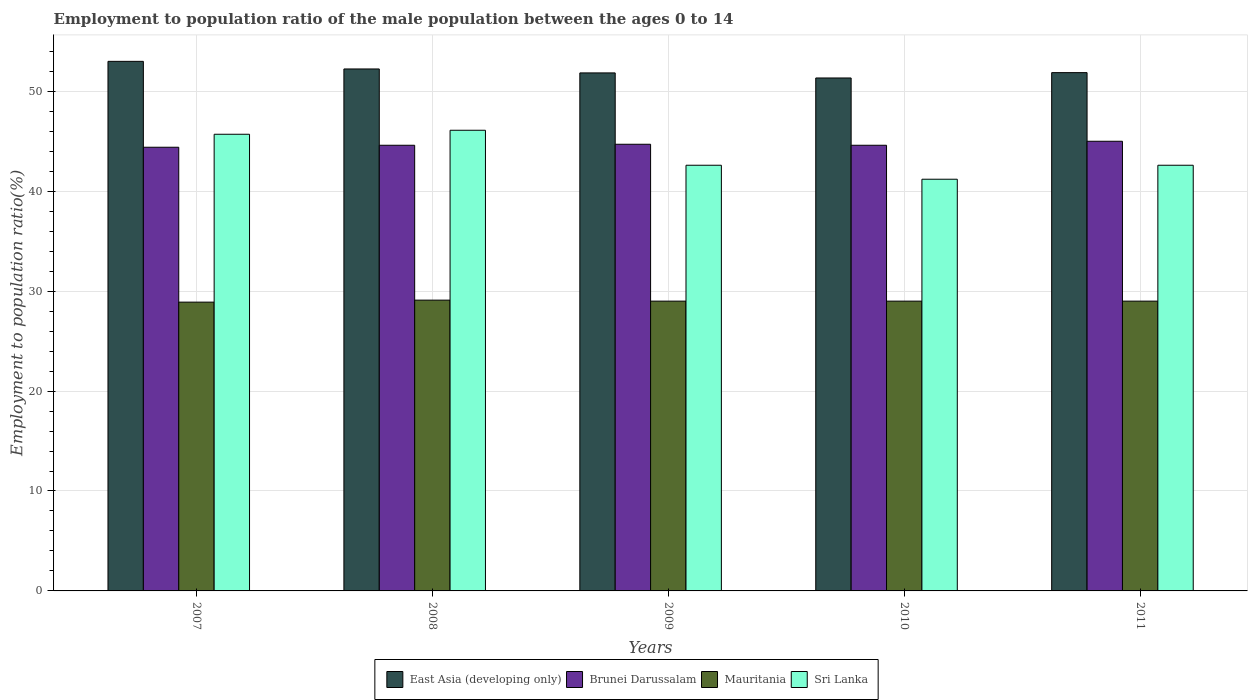How many different coloured bars are there?
Your answer should be compact. 4. How many groups of bars are there?
Offer a terse response. 5. Are the number of bars on each tick of the X-axis equal?
Provide a succinct answer. Yes. Across all years, what is the minimum employment to population ratio in Mauritania?
Your response must be concise. 28.9. What is the total employment to population ratio in Sri Lanka in the graph?
Provide a short and direct response. 218.2. What is the difference between the employment to population ratio in Brunei Darussalam in 2009 and that in 2011?
Ensure brevity in your answer.  -0.3. What is the difference between the employment to population ratio in Sri Lanka in 2007 and the employment to population ratio in Mauritania in 2009?
Offer a terse response. 16.7. What is the average employment to population ratio in East Asia (developing only) per year?
Make the answer very short. 52.05. In the year 2008, what is the difference between the employment to population ratio in Brunei Darussalam and employment to population ratio in Sri Lanka?
Ensure brevity in your answer.  -1.5. What is the ratio of the employment to population ratio in Mauritania in 2007 to that in 2008?
Ensure brevity in your answer.  0.99. Is the difference between the employment to population ratio in Brunei Darussalam in 2007 and 2010 greater than the difference between the employment to population ratio in Sri Lanka in 2007 and 2010?
Your answer should be compact. No. What is the difference between the highest and the second highest employment to population ratio in Brunei Darussalam?
Offer a very short reply. 0.3. What is the difference between the highest and the lowest employment to population ratio in Mauritania?
Make the answer very short. 0.2. Is the sum of the employment to population ratio in Sri Lanka in 2007 and 2009 greater than the maximum employment to population ratio in Mauritania across all years?
Your answer should be compact. Yes. What does the 2nd bar from the left in 2011 represents?
Offer a terse response. Brunei Darussalam. What does the 1st bar from the right in 2007 represents?
Your answer should be compact. Sri Lanka. Is it the case that in every year, the sum of the employment to population ratio in Sri Lanka and employment to population ratio in Mauritania is greater than the employment to population ratio in East Asia (developing only)?
Your answer should be compact. Yes. Are all the bars in the graph horizontal?
Provide a succinct answer. No. Does the graph contain any zero values?
Provide a short and direct response. No. How many legend labels are there?
Keep it short and to the point. 4. What is the title of the graph?
Offer a very short reply. Employment to population ratio of the male population between the ages 0 to 14. What is the label or title of the Y-axis?
Your answer should be compact. Employment to population ratio(%). What is the Employment to population ratio(%) of East Asia (developing only) in 2007?
Provide a succinct answer. 53. What is the Employment to population ratio(%) in Brunei Darussalam in 2007?
Give a very brief answer. 44.4. What is the Employment to population ratio(%) of Mauritania in 2007?
Your response must be concise. 28.9. What is the Employment to population ratio(%) of Sri Lanka in 2007?
Offer a very short reply. 45.7. What is the Employment to population ratio(%) in East Asia (developing only) in 2008?
Your answer should be very brief. 52.23. What is the Employment to population ratio(%) in Brunei Darussalam in 2008?
Offer a very short reply. 44.6. What is the Employment to population ratio(%) in Mauritania in 2008?
Provide a succinct answer. 29.1. What is the Employment to population ratio(%) of Sri Lanka in 2008?
Keep it short and to the point. 46.1. What is the Employment to population ratio(%) in East Asia (developing only) in 2009?
Your answer should be compact. 51.84. What is the Employment to population ratio(%) of Brunei Darussalam in 2009?
Your answer should be very brief. 44.7. What is the Employment to population ratio(%) in Sri Lanka in 2009?
Give a very brief answer. 42.6. What is the Employment to population ratio(%) in East Asia (developing only) in 2010?
Your answer should be compact. 51.33. What is the Employment to population ratio(%) in Brunei Darussalam in 2010?
Ensure brevity in your answer.  44.6. What is the Employment to population ratio(%) in Mauritania in 2010?
Provide a short and direct response. 29. What is the Employment to population ratio(%) in Sri Lanka in 2010?
Give a very brief answer. 41.2. What is the Employment to population ratio(%) of East Asia (developing only) in 2011?
Ensure brevity in your answer.  51.87. What is the Employment to population ratio(%) of Brunei Darussalam in 2011?
Keep it short and to the point. 45. What is the Employment to population ratio(%) of Sri Lanka in 2011?
Give a very brief answer. 42.6. Across all years, what is the maximum Employment to population ratio(%) of East Asia (developing only)?
Your response must be concise. 53. Across all years, what is the maximum Employment to population ratio(%) of Brunei Darussalam?
Offer a very short reply. 45. Across all years, what is the maximum Employment to population ratio(%) of Mauritania?
Your answer should be very brief. 29.1. Across all years, what is the maximum Employment to population ratio(%) in Sri Lanka?
Your answer should be very brief. 46.1. Across all years, what is the minimum Employment to population ratio(%) of East Asia (developing only)?
Ensure brevity in your answer.  51.33. Across all years, what is the minimum Employment to population ratio(%) in Brunei Darussalam?
Your answer should be compact. 44.4. Across all years, what is the minimum Employment to population ratio(%) in Mauritania?
Your answer should be compact. 28.9. Across all years, what is the minimum Employment to population ratio(%) of Sri Lanka?
Ensure brevity in your answer.  41.2. What is the total Employment to population ratio(%) in East Asia (developing only) in the graph?
Your answer should be compact. 260.27. What is the total Employment to population ratio(%) in Brunei Darussalam in the graph?
Your response must be concise. 223.3. What is the total Employment to population ratio(%) of Mauritania in the graph?
Your answer should be compact. 145. What is the total Employment to population ratio(%) of Sri Lanka in the graph?
Your answer should be compact. 218.2. What is the difference between the Employment to population ratio(%) in East Asia (developing only) in 2007 and that in 2008?
Your answer should be compact. 0.76. What is the difference between the Employment to population ratio(%) in Sri Lanka in 2007 and that in 2008?
Offer a terse response. -0.4. What is the difference between the Employment to population ratio(%) in East Asia (developing only) in 2007 and that in 2009?
Make the answer very short. 1.16. What is the difference between the Employment to population ratio(%) in Brunei Darussalam in 2007 and that in 2009?
Your response must be concise. -0.3. What is the difference between the Employment to population ratio(%) of Mauritania in 2007 and that in 2009?
Provide a short and direct response. -0.1. What is the difference between the Employment to population ratio(%) of Sri Lanka in 2007 and that in 2009?
Ensure brevity in your answer.  3.1. What is the difference between the Employment to population ratio(%) of East Asia (developing only) in 2007 and that in 2010?
Offer a very short reply. 1.66. What is the difference between the Employment to population ratio(%) in Mauritania in 2007 and that in 2010?
Make the answer very short. -0.1. What is the difference between the Employment to population ratio(%) of East Asia (developing only) in 2007 and that in 2011?
Ensure brevity in your answer.  1.13. What is the difference between the Employment to population ratio(%) of Brunei Darussalam in 2007 and that in 2011?
Your response must be concise. -0.6. What is the difference between the Employment to population ratio(%) of Sri Lanka in 2007 and that in 2011?
Offer a very short reply. 3.1. What is the difference between the Employment to population ratio(%) of East Asia (developing only) in 2008 and that in 2009?
Your response must be concise. 0.39. What is the difference between the Employment to population ratio(%) in East Asia (developing only) in 2008 and that in 2010?
Your answer should be compact. 0.9. What is the difference between the Employment to population ratio(%) in Mauritania in 2008 and that in 2010?
Your answer should be compact. 0.1. What is the difference between the Employment to population ratio(%) of East Asia (developing only) in 2008 and that in 2011?
Ensure brevity in your answer.  0.37. What is the difference between the Employment to population ratio(%) of Mauritania in 2008 and that in 2011?
Provide a succinct answer. 0.1. What is the difference between the Employment to population ratio(%) in Sri Lanka in 2008 and that in 2011?
Your response must be concise. 3.5. What is the difference between the Employment to population ratio(%) of East Asia (developing only) in 2009 and that in 2010?
Provide a succinct answer. 0.51. What is the difference between the Employment to population ratio(%) of Brunei Darussalam in 2009 and that in 2010?
Your answer should be very brief. 0.1. What is the difference between the Employment to population ratio(%) of Mauritania in 2009 and that in 2010?
Ensure brevity in your answer.  0. What is the difference between the Employment to population ratio(%) of East Asia (developing only) in 2009 and that in 2011?
Give a very brief answer. -0.03. What is the difference between the Employment to population ratio(%) in Mauritania in 2009 and that in 2011?
Provide a short and direct response. 0. What is the difference between the Employment to population ratio(%) in Sri Lanka in 2009 and that in 2011?
Your answer should be compact. 0. What is the difference between the Employment to population ratio(%) in East Asia (developing only) in 2010 and that in 2011?
Your answer should be very brief. -0.53. What is the difference between the Employment to population ratio(%) in Sri Lanka in 2010 and that in 2011?
Keep it short and to the point. -1.4. What is the difference between the Employment to population ratio(%) in East Asia (developing only) in 2007 and the Employment to population ratio(%) in Brunei Darussalam in 2008?
Your answer should be compact. 8.4. What is the difference between the Employment to population ratio(%) in East Asia (developing only) in 2007 and the Employment to population ratio(%) in Mauritania in 2008?
Provide a short and direct response. 23.9. What is the difference between the Employment to population ratio(%) of East Asia (developing only) in 2007 and the Employment to population ratio(%) of Sri Lanka in 2008?
Provide a short and direct response. 6.9. What is the difference between the Employment to population ratio(%) of Brunei Darussalam in 2007 and the Employment to population ratio(%) of Mauritania in 2008?
Make the answer very short. 15.3. What is the difference between the Employment to population ratio(%) of Mauritania in 2007 and the Employment to population ratio(%) of Sri Lanka in 2008?
Offer a terse response. -17.2. What is the difference between the Employment to population ratio(%) in East Asia (developing only) in 2007 and the Employment to population ratio(%) in Brunei Darussalam in 2009?
Ensure brevity in your answer.  8.3. What is the difference between the Employment to population ratio(%) of East Asia (developing only) in 2007 and the Employment to population ratio(%) of Mauritania in 2009?
Offer a terse response. 24. What is the difference between the Employment to population ratio(%) in East Asia (developing only) in 2007 and the Employment to population ratio(%) in Sri Lanka in 2009?
Keep it short and to the point. 10.4. What is the difference between the Employment to population ratio(%) in Mauritania in 2007 and the Employment to population ratio(%) in Sri Lanka in 2009?
Your answer should be compact. -13.7. What is the difference between the Employment to population ratio(%) in East Asia (developing only) in 2007 and the Employment to population ratio(%) in Brunei Darussalam in 2010?
Give a very brief answer. 8.4. What is the difference between the Employment to population ratio(%) of East Asia (developing only) in 2007 and the Employment to population ratio(%) of Mauritania in 2010?
Provide a short and direct response. 24. What is the difference between the Employment to population ratio(%) of East Asia (developing only) in 2007 and the Employment to population ratio(%) of Sri Lanka in 2010?
Offer a terse response. 11.8. What is the difference between the Employment to population ratio(%) of Brunei Darussalam in 2007 and the Employment to population ratio(%) of Mauritania in 2010?
Offer a very short reply. 15.4. What is the difference between the Employment to population ratio(%) in East Asia (developing only) in 2007 and the Employment to population ratio(%) in Brunei Darussalam in 2011?
Offer a very short reply. 8. What is the difference between the Employment to population ratio(%) in East Asia (developing only) in 2007 and the Employment to population ratio(%) in Mauritania in 2011?
Your answer should be very brief. 24. What is the difference between the Employment to population ratio(%) of East Asia (developing only) in 2007 and the Employment to population ratio(%) of Sri Lanka in 2011?
Provide a short and direct response. 10.4. What is the difference between the Employment to population ratio(%) of Brunei Darussalam in 2007 and the Employment to population ratio(%) of Mauritania in 2011?
Make the answer very short. 15.4. What is the difference between the Employment to population ratio(%) of Brunei Darussalam in 2007 and the Employment to population ratio(%) of Sri Lanka in 2011?
Keep it short and to the point. 1.8. What is the difference between the Employment to population ratio(%) of Mauritania in 2007 and the Employment to population ratio(%) of Sri Lanka in 2011?
Offer a terse response. -13.7. What is the difference between the Employment to population ratio(%) of East Asia (developing only) in 2008 and the Employment to population ratio(%) of Brunei Darussalam in 2009?
Offer a terse response. 7.53. What is the difference between the Employment to population ratio(%) of East Asia (developing only) in 2008 and the Employment to population ratio(%) of Mauritania in 2009?
Provide a short and direct response. 23.23. What is the difference between the Employment to population ratio(%) of East Asia (developing only) in 2008 and the Employment to population ratio(%) of Sri Lanka in 2009?
Keep it short and to the point. 9.63. What is the difference between the Employment to population ratio(%) in Brunei Darussalam in 2008 and the Employment to population ratio(%) in Mauritania in 2009?
Give a very brief answer. 15.6. What is the difference between the Employment to population ratio(%) in Mauritania in 2008 and the Employment to population ratio(%) in Sri Lanka in 2009?
Provide a short and direct response. -13.5. What is the difference between the Employment to population ratio(%) of East Asia (developing only) in 2008 and the Employment to population ratio(%) of Brunei Darussalam in 2010?
Offer a terse response. 7.63. What is the difference between the Employment to population ratio(%) in East Asia (developing only) in 2008 and the Employment to population ratio(%) in Mauritania in 2010?
Offer a terse response. 23.23. What is the difference between the Employment to population ratio(%) of East Asia (developing only) in 2008 and the Employment to population ratio(%) of Sri Lanka in 2010?
Your answer should be compact. 11.03. What is the difference between the Employment to population ratio(%) of Brunei Darussalam in 2008 and the Employment to population ratio(%) of Mauritania in 2010?
Ensure brevity in your answer.  15.6. What is the difference between the Employment to population ratio(%) in Mauritania in 2008 and the Employment to population ratio(%) in Sri Lanka in 2010?
Offer a very short reply. -12.1. What is the difference between the Employment to population ratio(%) in East Asia (developing only) in 2008 and the Employment to population ratio(%) in Brunei Darussalam in 2011?
Offer a terse response. 7.23. What is the difference between the Employment to population ratio(%) in East Asia (developing only) in 2008 and the Employment to population ratio(%) in Mauritania in 2011?
Make the answer very short. 23.23. What is the difference between the Employment to population ratio(%) of East Asia (developing only) in 2008 and the Employment to population ratio(%) of Sri Lanka in 2011?
Ensure brevity in your answer.  9.63. What is the difference between the Employment to population ratio(%) in Brunei Darussalam in 2008 and the Employment to population ratio(%) in Sri Lanka in 2011?
Offer a very short reply. 2. What is the difference between the Employment to population ratio(%) of Mauritania in 2008 and the Employment to population ratio(%) of Sri Lanka in 2011?
Your response must be concise. -13.5. What is the difference between the Employment to population ratio(%) of East Asia (developing only) in 2009 and the Employment to population ratio(%) of Brunei Darussalam in 2010?
Your answer should be compact. 7.24. What is the difference between the Employment to population ratio(%) in East Asia (developing only) in 2009 and the Employment to population ratio(%) in Mauritania in 2010?
Make the answer very short. 22.84. What is the difference between the Employment to population ratio(%) in East Asia (developing only) in 2009 and the Employment to population ratio(%) in Sri Lanka in 2010?
Your answer should be compact. 10.64. What is the difference between the Employment to population ratio(%) in Brunei Darussalam in 2009 and the Employment to population ratio(%) in Mauritania in 2010?
Your answer should be very brief. 15.7. What is the difference between the Employment to population ratio(%) of Mauritania in 2009 and the Employment to population ratio(%) of Sri Lanka in 2010?
Offer a very short reply. -12.2. What is the difference between the Employment to population ratio(%) in East Asia (developing only) in 2009 and the Employment to population ratio(%) in Brunei Darussalam in 2011?
Provide a short and direct response. 6.84. What is the difference between the Employment to population ratio(%) of East Asia (developing only) in 2009 and the Employment to population ratio(%) of Mauritania in 2011?
Provide a short and direct response. 22.84. What is the difference between the Employment to population ratio(%) in East Asia (developing only) in 2009 and the Employment to population ratio(%) in Sri Lanka in 2011?
Your response must be concise. 9.24. What is the difference between the Employment to population ratio(%) in East Asia (developing only) in 2010 and the Employment to population ratio(%) in Brunei Darussalam in 2011?
Your response must be concise. 6.33. What is the difference between the Employment to population ratio(%) in East Asia (developing only) in 2010 and the Employment to population ratio(%) in Mauritania in 2011?
Your answer should be very brief. 22.33. What is the difference between the Employment to population ratio(%) of East Asia (developing only) in 2010 and the Employment to population ratio(%) of Sri Lanka in 2011?
Give a very brief answer. 8.73. What is the difference between the Employment to population ratio(%) in Mauritania in 2010 and the Employment to population ratio(%) in Sri Lanka in 2011?
Offer a very short reply. -13.6. What is the average Employment to population ratio(%) of East Asia (developing only) per year?
Offer a very short reply. 52.05. What is the average Employment to population ratio(%) in Brunei Darussalam per year?
Your answer should be very brief. 44.66. What is the average Employment to population ratio(%) of Mauritania per year?
Offer a terse response. 29. What is the average Employment to population ratio(%) in Sri Lanka per year?
Make the answer very short. 43.64. In the year 2007, what is the difference between the Employment to population ratio(%) of East Asia (developing only) and Employment to population ratio(%) of Brunei Darussalam?
Your answer should be very brief. 8.6. In the year 2007, what is the difference between the Employment to population ratio(%) in East Asia (developing only) and Employment to population ratio(%) in Mauritania?
Offer a very short reply. 24.1. In the year 2007, what is the difference between the Employment to population ratio(%) in East Asia (developing only) and Employment to population ratio(%) in Sri Lanka?
Provide a succinct answer. 7.3. In the year 2007, what is the difference between the Employment to population ratio(%) in Mauritania and Employment to population ratio(%) in Sri Lanka?
Make the answer very short. -16.8. In the year 2008, what is the difference between the Employment to population ratio(%) in East Asia (developing only) and Employment to population ratio(%) in Brunei Darussalam?
Keep it short and to the point. 7.63. In the year 2008, what is the difference between the Employment to population ratio(%) of East Asia (developing only) and Employment to population ratio(%) of Mauritania?
Your response must be concise. 23.13. In the year 2008, what is the difference between the Employment to population ratio(%) in East Asia (developing only) and Employment to population ratio(%) in Sri Lanka?
Give a very brief answer. 6.13. In the year 2008, what is the difference between the Employment to population ratio(%) in Brunei Darussalam and Employment to population ratio(%) in Sri Lanka?
Provide a short and direct response. -1.5. In the year 2008, what is the difference between the Employment to population ratio(%) in Mauritania and Employment to population ratio(%) in Sri Lanka?
Your answer should be compact. -17. In the year 2009, what is the difference between the Employment to population ratio(%) in East Asia (developing only) and Employment to population ratio(%) in Brunei Darussalam?
Make the answer very short. 7.14. In the year 2009, what is the difference between the Employment to population ratio(%) in East Asia (developing only) and Employment to population ratio(%) in Mauritania?
Your answer should be compact. 22.84. In the year 2009, what is the difference between the Employment to population ratio(%) of East Asia (developing only) and Employment to population ratio(%) of Sri Lanka?
Your answer should be very brief. 9.24. In the year 2009, what is the difference between the Employment to population ratio(%) in Brunei Darussalam and Employment to population ratio(%) in Mauritania?
Offer a very short reply. 15.7. In the year 2009, what is the difference between the Employment to population ratio(%) in Brunei Darussalam and Employment to population ratio(%) in Sri Lanka?
Make the answer very short. 2.1. In the year 2010, what is the difference between the Employment to population ratio(%) of East Asia (developing only) and Employment to population ratio(%) of Brunei Darussalam?
Your answer should be very brief. 6.73. In the year 2010, what is the difference between the Employment to population ratio(%) of East Asia (developing only) and Employment to population ratio(%) of Mauritania?
Your response must be concise. 22.33. In the year 2010, what is the difference between the Employment to population ratio(%) in East Asia (developing only) and Employment to population ratio(%) in Sri Lanka?
Ensure brevity in your answer.  10.13. In the year 2011, what is the difference between the Employment to population ratio(%) in East Asia (developing only) and Employment to population ratio(%) in Brunei Darussalam?
Provide a short and direct response. 6.87. In the year 2011, what is the difference between the Employment to population ratio(%) in East Asia (developing only) and Employment to population ratio(%) in Mauritania?
Give a very brief answer. 22.87. In the year 2011, what is the difference between the Employment to population ratio(%) of East Asia (developing only) and Employment to population ratio(%) of Sri Lanka?
Your answer should be very brief. 9.27. In the year 2011, what is the difference between the Employment to population ratio(%) in Brunei Darussalam and Employment to population ratio(%) in Mauritania?
Keep it short and to the point. 16. In the year 2011, what is the difference between the Employment to population ratio(%) of Mauritania and Employment to population ratio(%) of Sri Lanka?
Keep it short and to the point. -13.6. What is the ratio of the Employment to population ratio(%) in East Asia (developing only) in 2007 to that in 2008?
Offer a terse response. 1.01. What is the ratio of the Employment to population ratio(%) of Mauritania in 2007 to that in 2008?
Keep it short and to the point. 0.99. What is the ratio of the Employment to population ratio(%) of East Asia (developing only) in 2007 to that in 2009?
Give a very brief answer. 1.02. What is the ratio of the Employment to population ratio(%) of Sri Lanka in 2007 to that in 2009?
Your answer should be compact. 1.07. What is the ratio of the Employment to population ratio(%) of East Asia (developing only) in 2007 to that in 2010?
Your response must be concise. 1.03. What is the ratio of the Employment to population ratio(%) in Mauritania in 2007 to that in 2010?
Keep it short and to the point. 1. What is the ratio of the Employment to population ratio(%) of Sri Lanka in 2007 to that in 2010?
Your answer should be compact. 1.11. What is the ratio of the Employment to population ratio(%) of East Asia (developing only) in 2007 to that in 2011?
Give a very brief answer. 1.02. What is the ratio of the Employment to population ratio(%) in Brunei Darussalam in 2007 to that in 2011?
Offer a very short reply. 0.99. What is the ratio of the Employment to population ratio(%) of Mauritania in 2007 to that in 2011?
Your answer should be very brief. 1. What is the ratio of the Employment to population ratio(%) of Sri Lanka in 2007 to that in 2011?
Your answer should be very brief. 1.07. What is the ratio of the Employment to population ratio(%) of East Asia (developing only) in 2008 to that in 2009?
Your answer should be very brief. 1.01. What is the ratio of the Employment to population ratio(%) of Brunei Darussalam in 2008 to that in 2009?
Make the answer very short. 1. What is the ratio of the Employment to population ratio(%) of Sri Lanka in 2008 to that in 2009?
Offer a terse response. 1.08. What is the ratio of the Employment to population ratio(%) in East Asia (developing only) in 2008 to that in 2010?
Offer a terse response. 1.02. What is the ratio of the Employment to population ratio(%) of Sri Lanka in 2008 to that in 2010?
Make the answer very short. 1.12. What is the ratio of the Employment to population ratio(%) in East Asia (developing only) in 2008 to that in 2011?
Provide a short and direct response. 1.01. What is the ratio of the Employment to population ratio(%) in Brunei Darussalam in 2008 to that in 2011?
Make the answer very short. 0.99. What is the ratio of the Employment to population ratio(%) in Sri Lanka in 2008 to that in 2011?
Provide a succinct answer. 1.08. What is the ratio of the Employment to population ratio(%) in East Asia (developing only) in 2009 to that in 2010?
Give a very brief answer. 1.01. What is the ratio of the Employment to population ratio(%) of Brunei Darussalam in 2009 to that in 2010?
Make the answer very short. 1. What is the ratio of the Employment to population ratio(%) of Mauritania in 2009 to that in 2010?
Offer a very short reply. 1. What is the ratio of the Employment to population ratio(%) in Sri Lanka in 2009 to that in 2010?
Make the answer very short. 1.03. What is the ratio of the Employment to population ratio(%) in East Asia (developing only) in 2009 to that in 2011?
Give a very brief answer. 1. What is the ratio of the Employment to population ratio(%) in Sri Lanka in 2009 to that in 2011?
Give a very brief answer. 1. What is the ratio of the Employment to population ratio(%) of Mauritania in 2010 to that in 2011?
Your answer should be very brief. 1. What is the ratio of the Employment to population ratio(%) in Sri Lanka in 2010 to that in 2011?
Offer a very short reply. 0.97. What is the difference between the highest and the second highest Employment to population ratio(%) of East Asia (developing only)?
Make the answer very short. 0.76. What is the difference between the highest and the second highest Employment to population ratio(%) in Brunei Darussalam?
Ensure brevity in your answer.  0.3. What is the difference between the highest and the lowest Employment to population ratio(%) of East Asia (developing only)?
Keep it short and to the point. 1.66. What is the difference between the highest and the lowest Employment to population ratio(%) of Mauritania?
Provide a succinct answer. 0.2. 